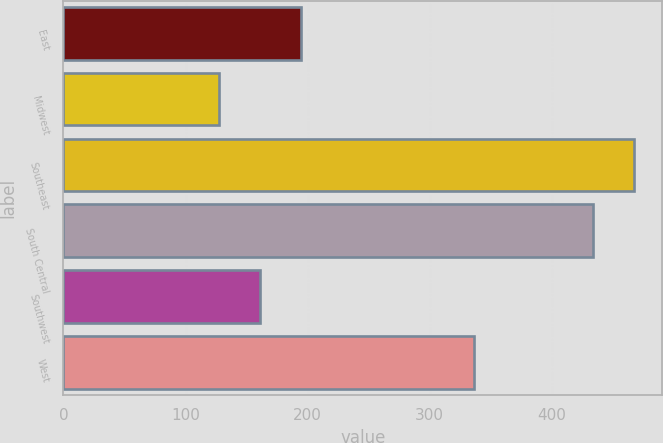Convert chart. <chart><loc_0><loc_0><loc_500><loc_500><bar_chart><fcel>East<fcel>Midwest<fcel>Southeast<fcel>South Central<fcel>Southwest<fcel>West<nl><fcel>194.92<fcel>127.4<fcel>467.26<fcel>433.5<fcel>161.16<fcel>336.6<nl></chart> 